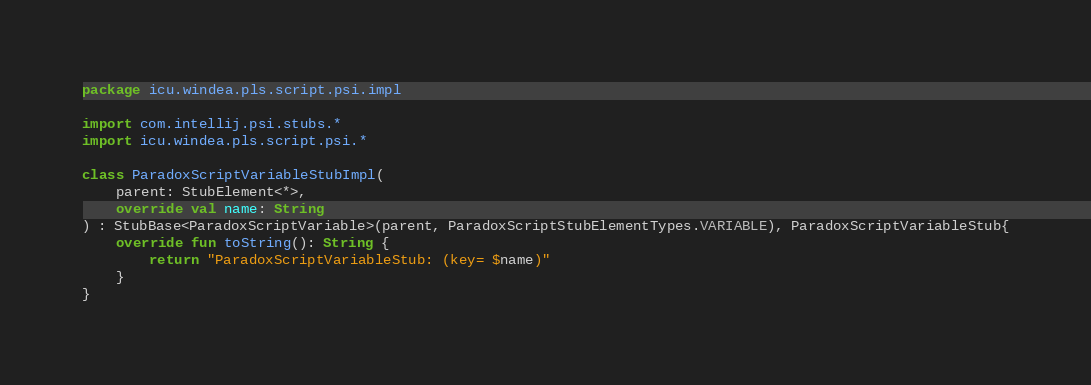Convert code to text. <code><loc_0><loc_0><loc_500><loc_500><_Kotlin_>package icu.windea.pls.script.psi.impl

import com.intellij.psi.stubs.*
import icu.windea.pls.script.psi.*

class ParadoxScriptVariableStubImpl(
	parent: StubElement<*>,
	override val name: String
) : StubBase<ParadoxScriptVariable>(parent, ParadoxScriptStubElementTypes.VARIABLE), ParadoxScriptVariableStub{
	override fun toString(): String {
		return "ParadoxScriptVariableStub: (key= $name)"
	}
}

</code> 